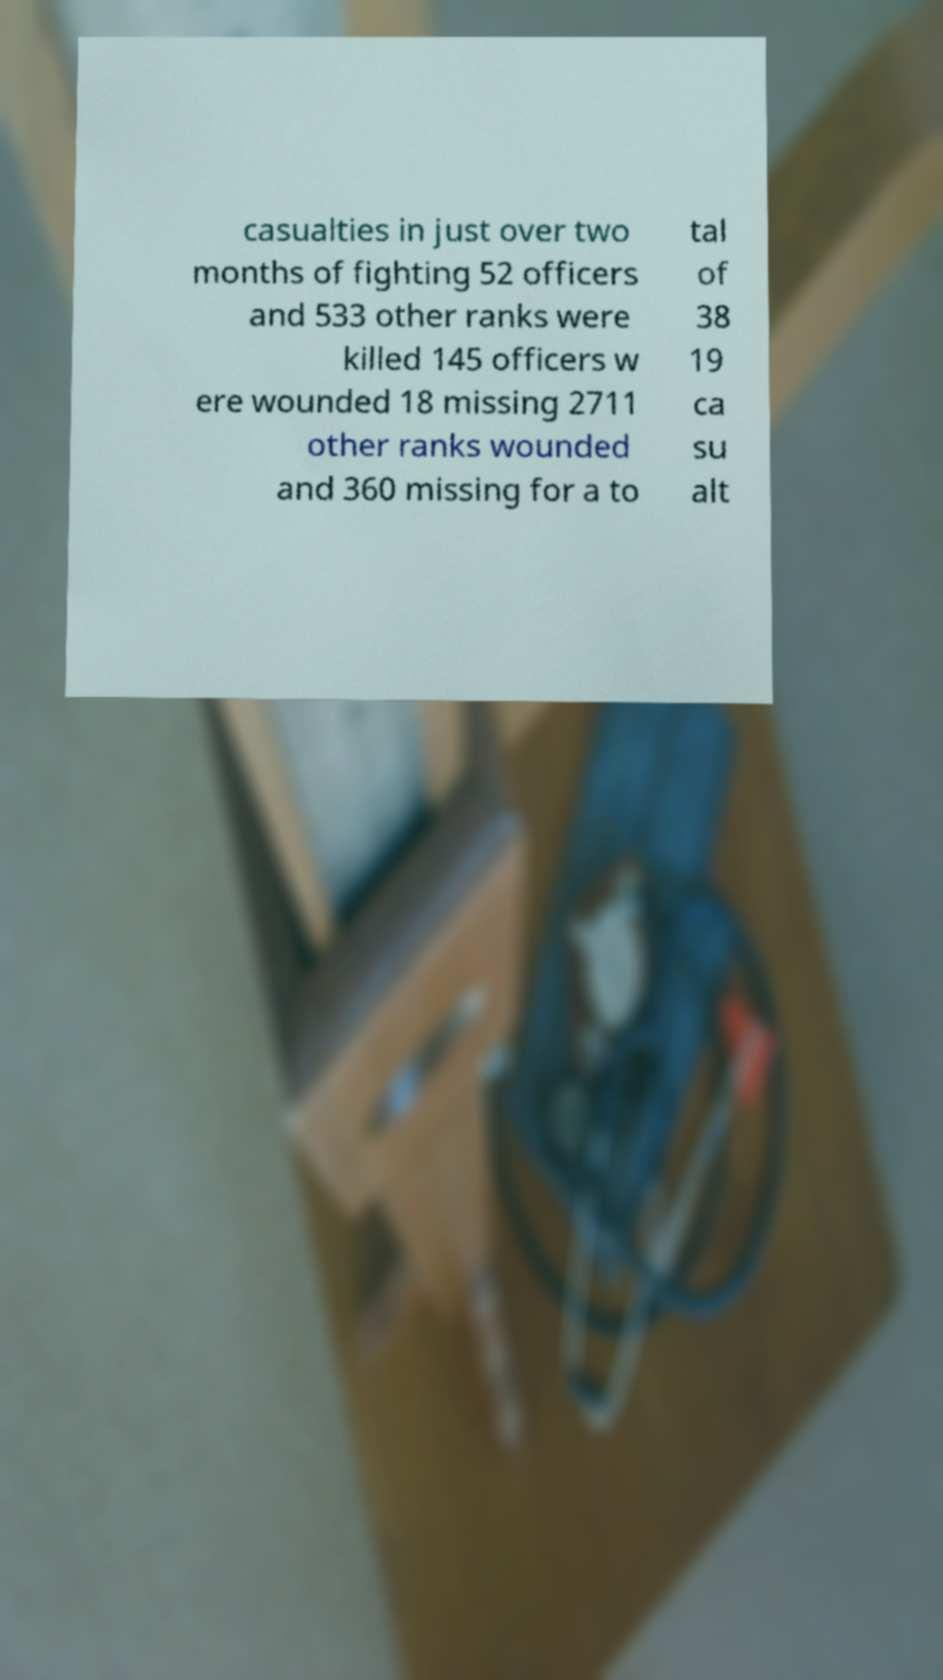Please read and relay the text visible in this image. What does it say? casualties in just over two months of fighting 52 officers and 533 other ranks were killed 145 officers w ere wounded 18 missing 2711 other ranks wounded and 360 missing for a to tal of 38 19 ca su alt 